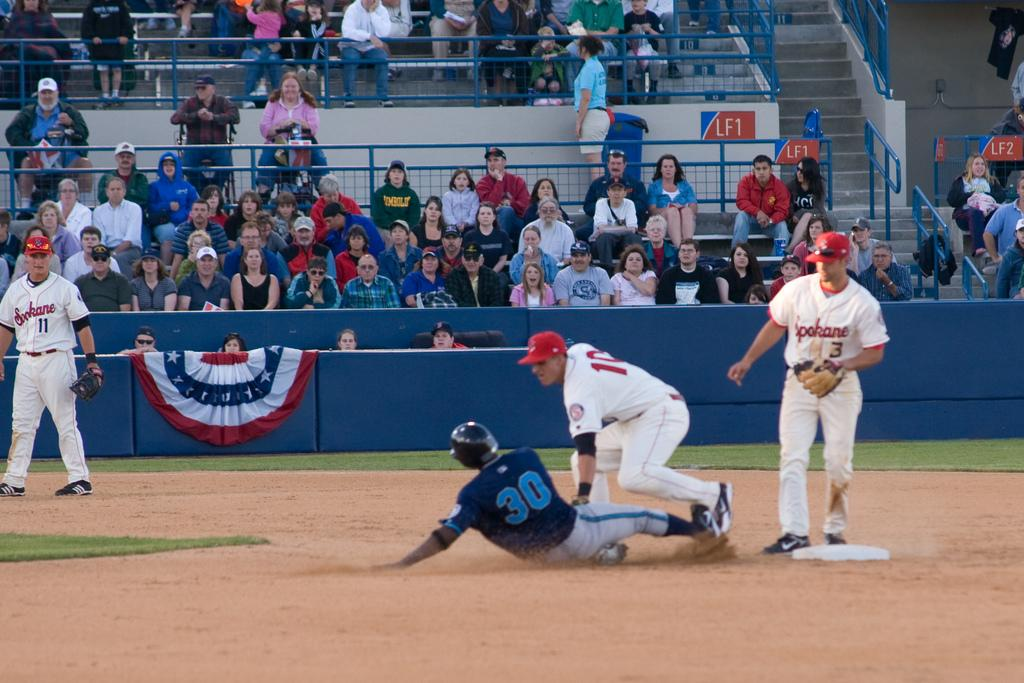<image>
Describe the image concisely. Baseball player wearing number 30 running into base. 